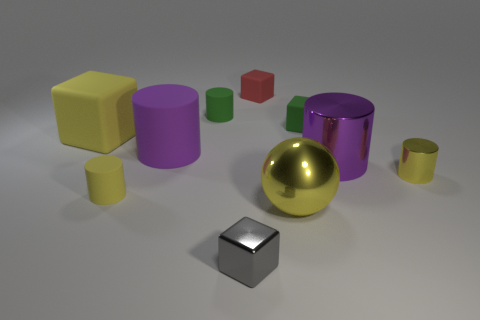Subtract 1 cylinders. How many cylinders are left? 4 Subtract all green cylinders. How many cylinders are left? 4 Subtract all tiny green cylinders. How many cylinders are left? 4 Subtract all brown cylinders. Subtract all red spheres. How many cylinders are left? 5 Subtract all balls. How many objects are left? 9 Subtract all yellow rubber cylinders. Subtract all yellow matte cylinders. How many objects are left? 8 Add 3 gray metal things. How many gray metal things are left? 4 Add 9 yellow spheres. How many yellow spheres exist? 10 Subtract 0 purple spheres. How many objects are left? 10 